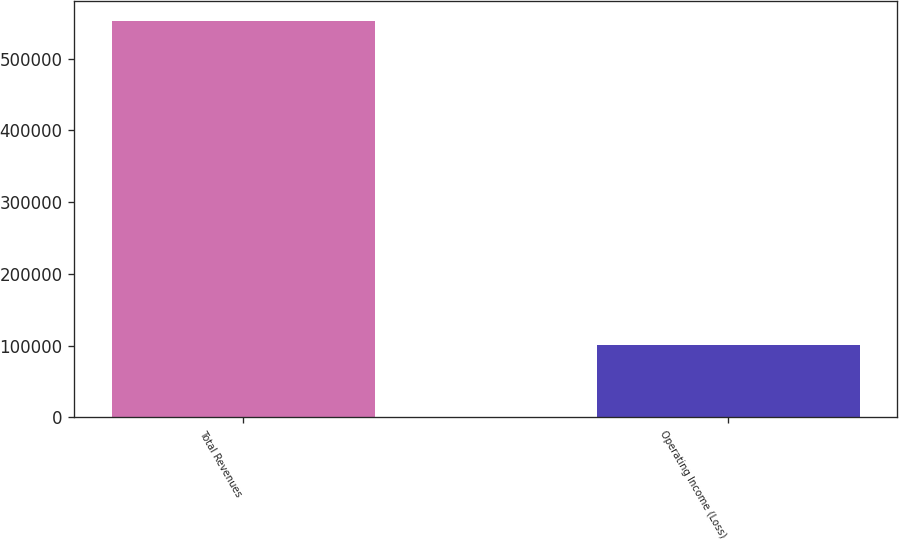<chart> <loc_0><loc_0><loc_500><loc_500><bar_chart><fcel>Total Revenues<fcel>Operating Income (Loss)<nl><fcel>552501<fcel>100469<nl></chart> 